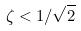<formula> <loc_0><loc_0><loc_500><loc_500>\zeta < 1 / \sqrt { 2 }</formula> 